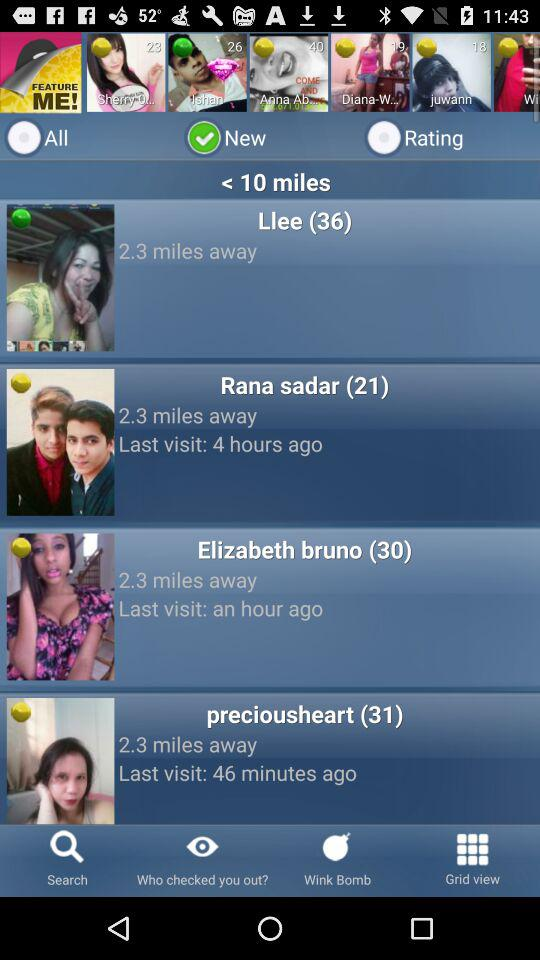How many miles away is Llee? Llee is 2.3 miles away. 